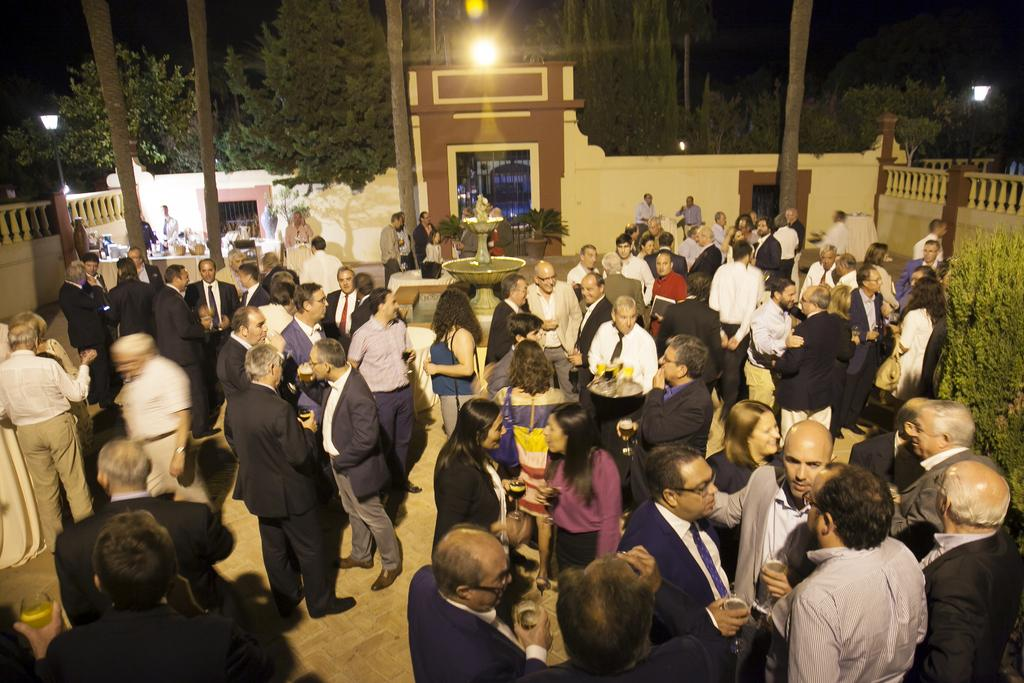What can be seen on the right side of the image? There are people standing and plants on the right side of the image. What is the background of the image? There is a wall visible in the image, and there are trees present as well. How many people are in the image? The number of people cannot be determined from the provided facts, but there are people on the right side of the image. What type of advertisement can be seen on the wall in the image? There is no advertisement present on the wall in the image. What reward is being given to the people in the image? There is no indication of a reward being given to the people in the image. 